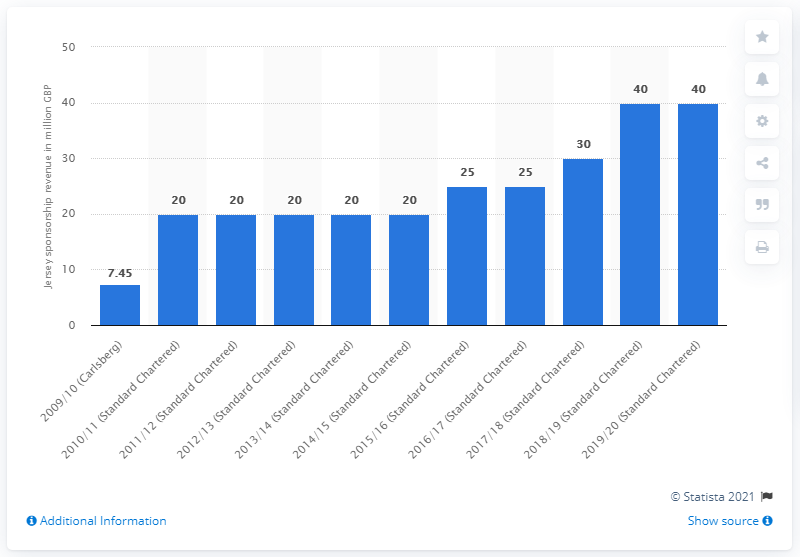Specify some key components in this picture. Liverpool FC received 40 million GBP from Standard Chartered in the 2019/2020 season. 